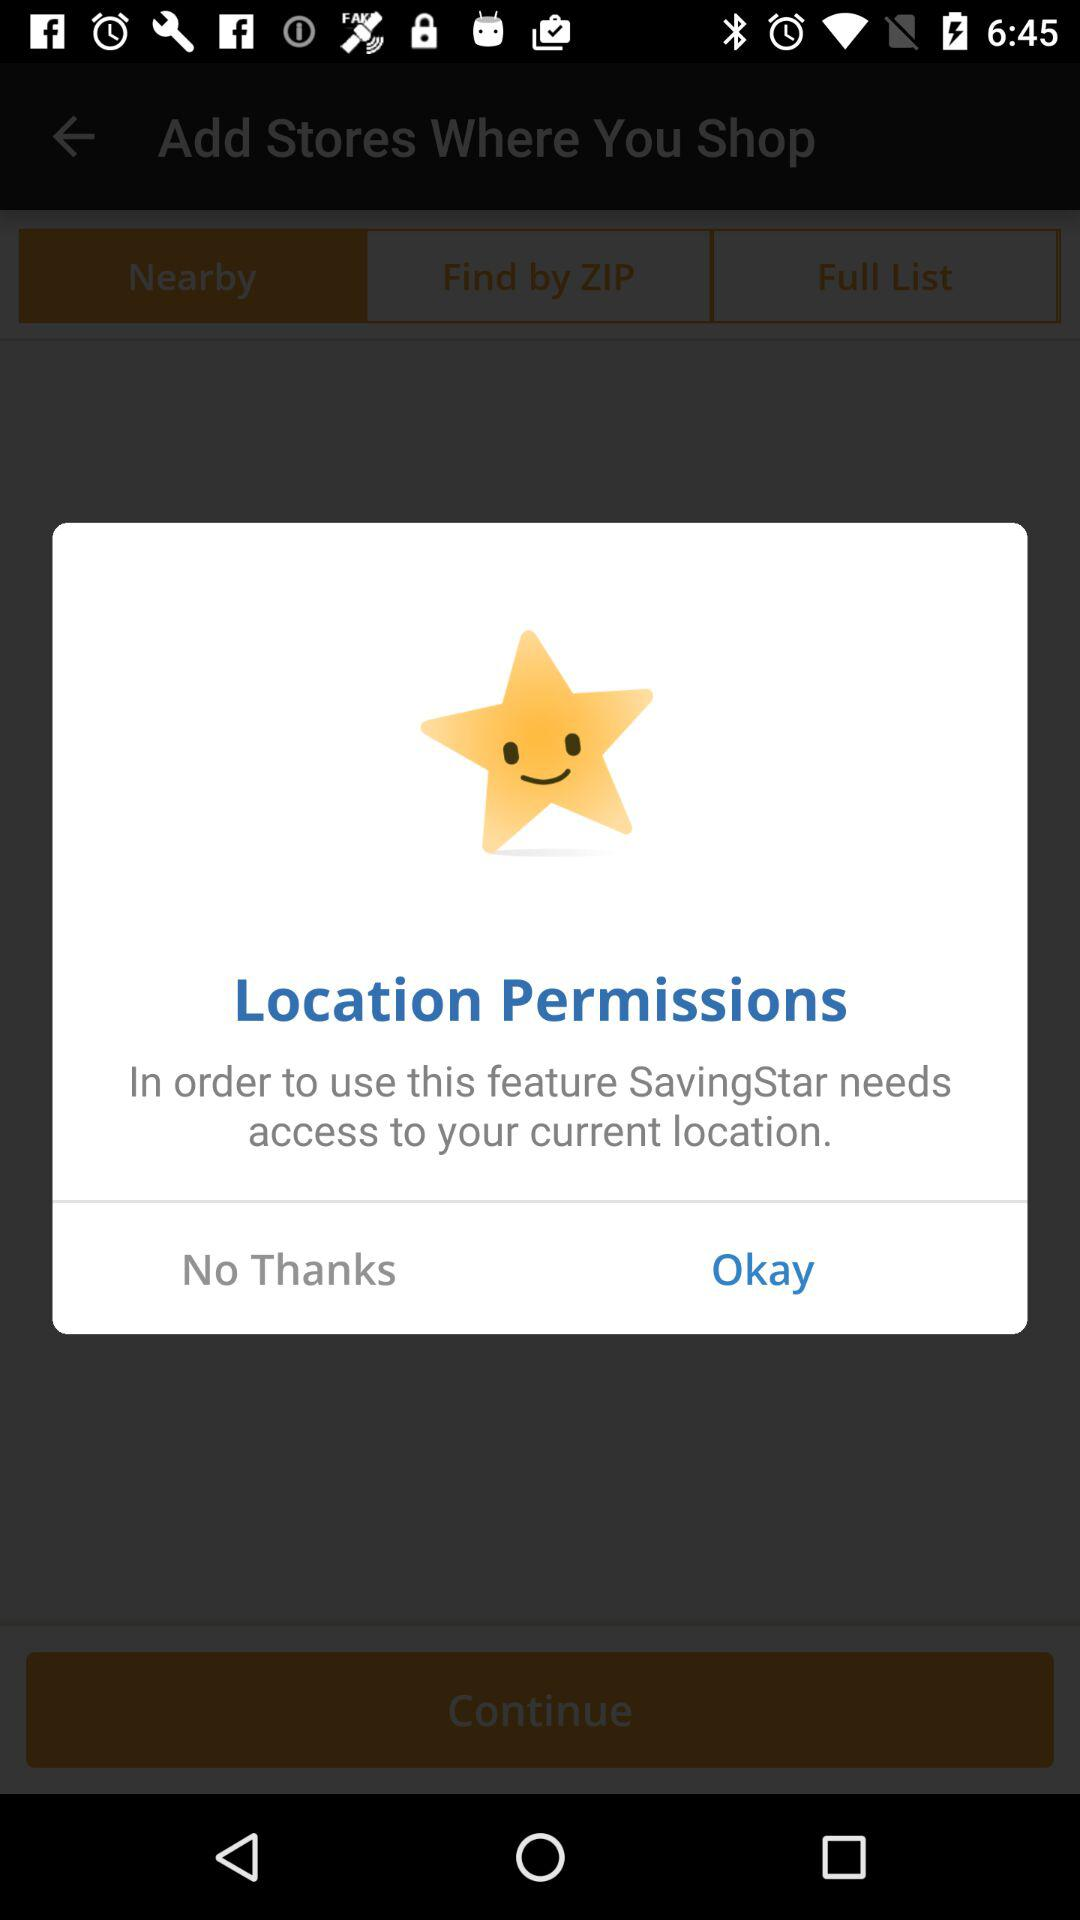What application is asking for permission? The application that is asking for permission is "SavingStar". 